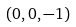<formula> <loc_0><loc_0><loc_500><loc_500>( 0 , 0 , - 1 )</formula> 